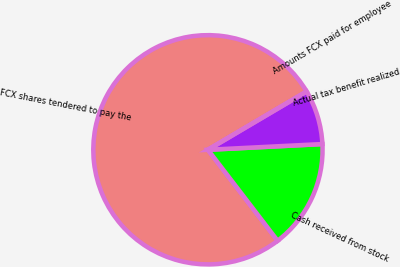Convert chart to OTSL. <chart><loc_0><loc_0><loc_500><loc_500><pie_chart><fcel>FCX shares tendered to pay the<fcel>Cash received from stock<fcel>Actual tax benefit realized<fcel>Amounts FCX paid for employee<nl><fcel>76.92%<fcel>15.39%<fcel>7.69%<fcel>0.0%<nl></chart> 